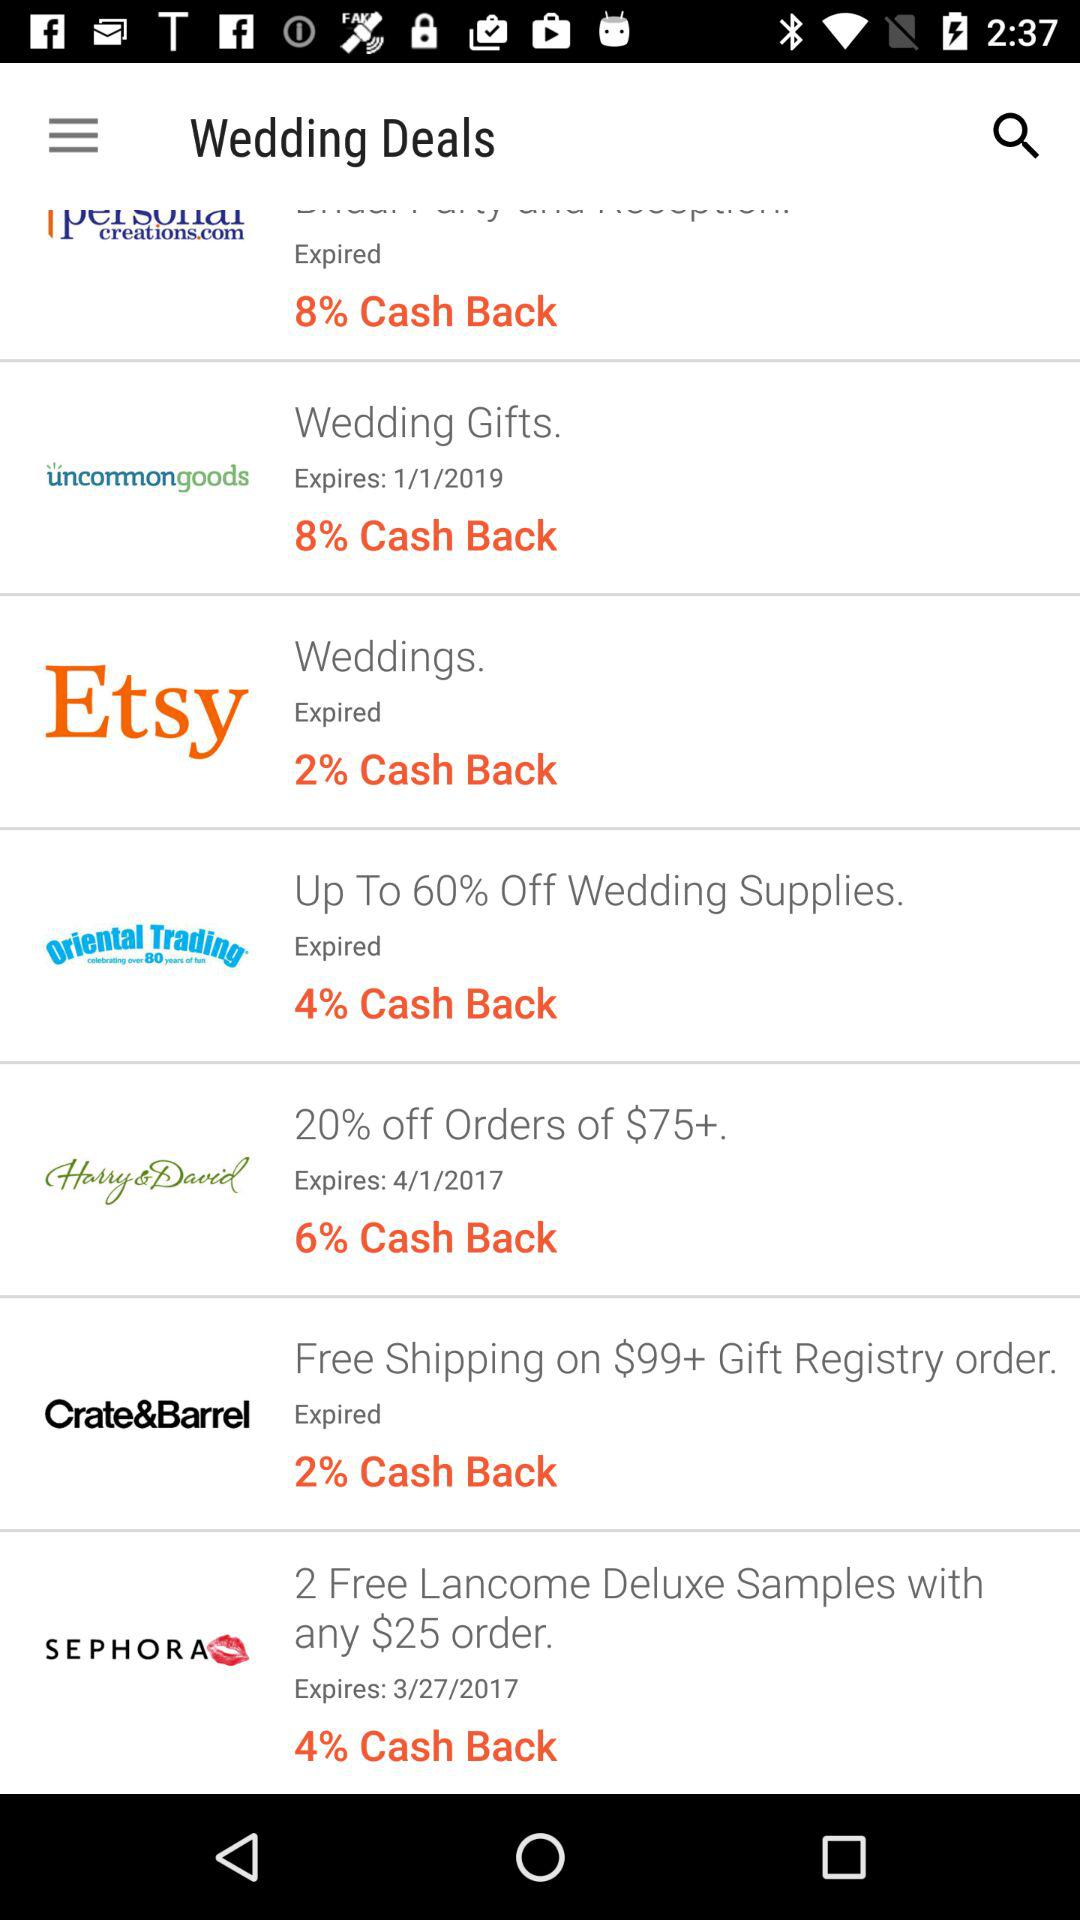How much is off on wedding supplies? It is up to 60%. 